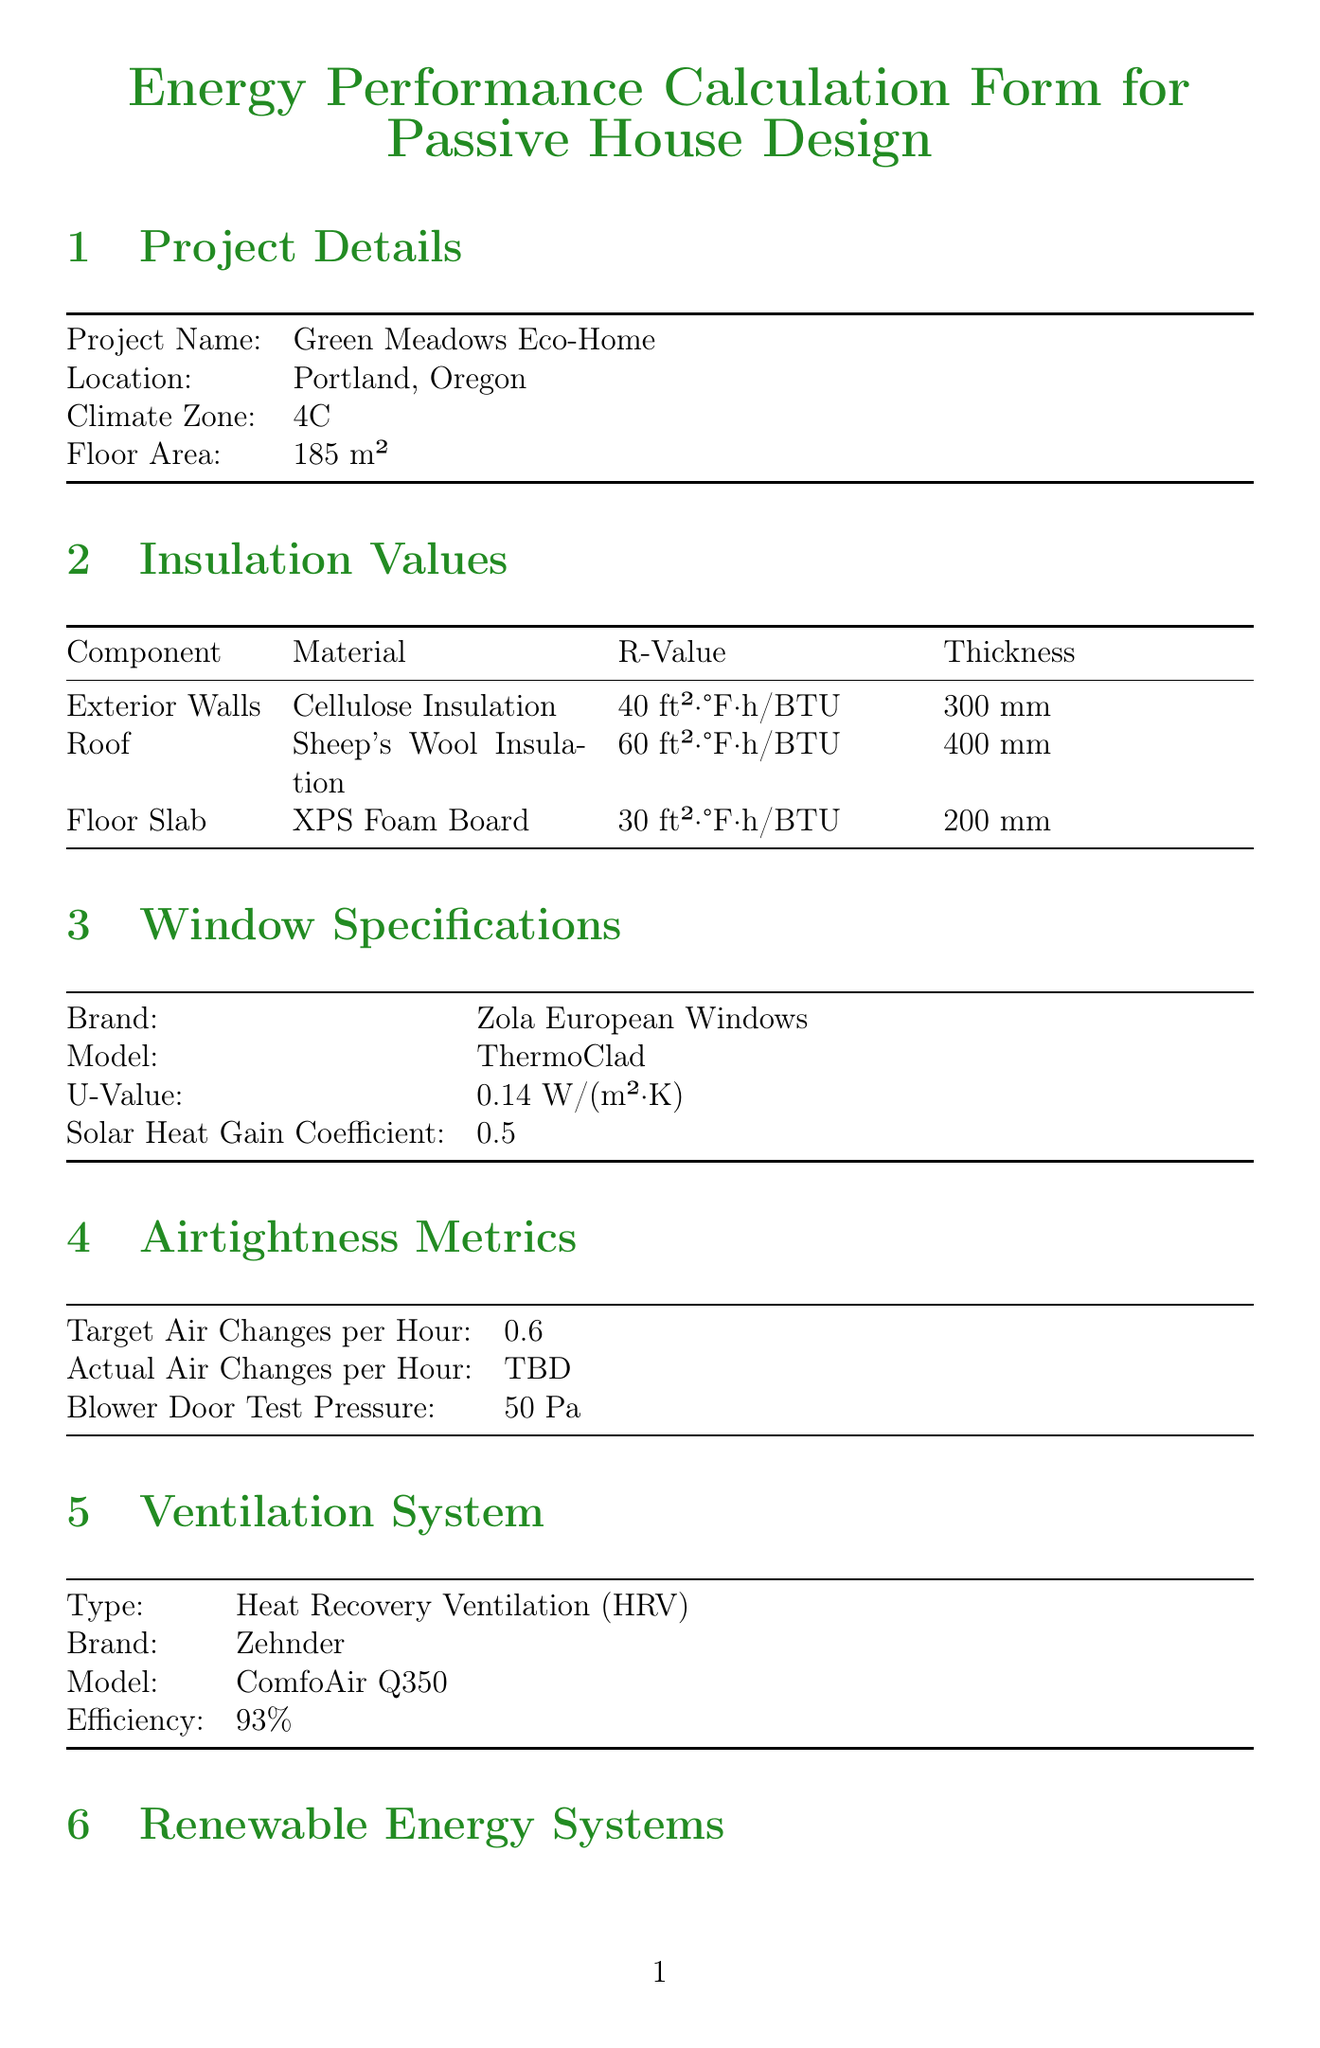What is the project name? The project name is specified in the document under Project Details.
Answer: Green Meadows Eco-Home What is the U-Value of the windows? The U-Value is listed in the Window Specifications section.
Answer: 0.14 W/(m²·K) What type of insulation is used for the roof? The material for the roof insulation is detailed in the Insulation Values section.
Answer: Sheep's Wool Insulation What is the efficiency of the heating system? The efficiency is mentioned in the Heating System section and refers to the COP.
Answer: 4.5 COP What are the target air changes per hour? The target air changes per hour are indicated in the Airtightness Metrics section.
Answer: 0.6 What is the estimated annual production of the Solar PV system? The estimated annual production is provided under Renewable Energy Systems for Solar PV.
Answer: 6500 kWh Is the building targeting Passivhaus Standard certification? The certification targets section indicates whether Passivhaus Standard is being targeted.
Answer: Yes What is the thickness of the floor slab insulation? The thickness is specified in the Insulation Values section for Floor Slab.
Answer: 200 mm What brand of windows is being used? The brand is mentioned in the Window Specifications section.
Answer: Zola European Windows 